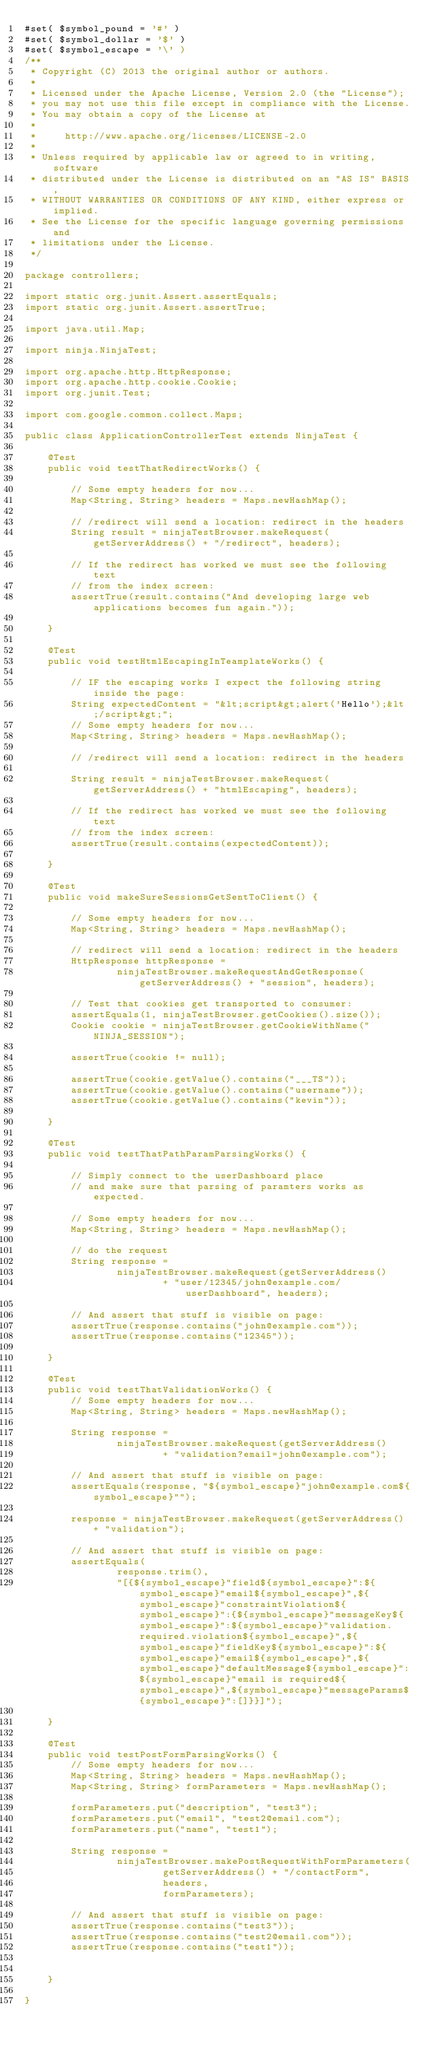Convert code to text. <code><loc_0><loc_0><loc_500><loc_500><_Java_>#set( $symbol_pound = '#' )
#set( $symbol_dollar = '$' )
#set( $symbol_escape = '\' )
/**
 * Copyright (C) 2013 the original author or authors.
 *
 * Licensed under the Apache License, Version 2.0 (the "License");
 * you may not use this file except in compliance with the License.
 * You may obtain a copy of the License at
 *
 *     http://www.apache.org/licenses/LICENSE-2.0
 *
 * Unless required by applicable law or agreed to in writing, software
 * distributed under the License is distributed on an "AS IS" BASIS,
 * WITHOUT WARRANTIES OR CONDITIONS OF ANY KIND, either express or implied.
 * See the License for the specific language governing permissions and
 * limitations under the License.
 */

package controllers;

import static org.junit.Assert.assertEquals;
import static org.junit.Assert.assertTrue;

import java.util.Map;

import ninja.NinjaTest;

import org.apache.http.HttpResponse;
import org.apache.http.cookie.Cookie;
import org.junit.Test;

import com.google.common.collect.Maps;

public class ApplicationControllerTest extends NinjaTest {

    @Test
    public void testThatRedirectWorks() {

        // Some empty headers for now...
        Map<String, String> headers = Maps.newHashMap();

        // /redirect will send a location: redirect in the headers
        String result = ninjaTestBrowser.makeRequest(getServerAddress() + "/redirect", headers);

        // If the redirect has worked we must see the following text
        // from the index screen:
        assertTrue(result.contains("And developing large web applications becomes fun again."));

    }

    @Test
    public void testHtmlEscapingInTeamplateWorks() {

        // IF the escaping works I expect the following string inside the page:
        String expectedContent = "&lt;script&gt;alert('Hello');&lt;/script&gt;";
        // Some empty headers for now...
        Map<String, String> headers = Maps.newHashMap();

        // /redirect will send a location: redirect in the headers

        String result = ninjaTestBrowser.makeRequest(getServerAddress() + "htmlEscaping", headers);

        // If the redirect has worked we must see the following text
        // from the index screen:
        assertTrue(result.contains(expectedContent));

    }

    @Test
    public void makeSureSessionsGetSentToClient() {

        // Some empty headers for now...
        Map<String, String> headers = Maps.newHashMap();

        // redirect will send a location: redirect in the headers
        HttpResponse httpResponse =
                ninjaTestBrowser.makeRequestAndGetResponse(getServerAddress() + "session", headers);

        // Test that cookies get transported to consumer:
        assertEquals(1, ninjaTestBrowser.getCookies().size());
        Cookie cookie = ninjaTestBrowser.getCookieWithName("NINJA_SESSION");

        assertTrue(cookie != null);

        assertTrue(cookie.getValue().contains("___TS"));
        assertTrue(cookie.getValue().contains("username"));
        assertTrue(cookie.getValue().contains("kevin"));

    }

    @Test
    public void testThatPathParamParsingWorks() {

        // Simply connect to the userDashboard place
        // and make sure that parsing of paramters works as expected.

        // Some empty headers for now...
        Map<String, String> headers = Maps.newHashMap();

        // do the request
        String response =
                ninjaTestBrowser.makeRequest(getServerAddress()
                        + "user/12345/john@example.com/userDashboard", headers);

        // And assert that stuff is visible on page:
        assertTrue(response.contains("john@example.com"));
        assertTrue(response.contains("12345"));

    }

    @Test
    public void testThatValidationWorks() {
        // Some empty headers for now...
        Map<String, String> headers = Maps.newHashMap();

        String response =
                ninjaTestBrowser.makeRequest(getServerAddress()
                        + "validation?email=john@example.com");

        // And assert that stuff is visible on page:
        assertEquals(response, "${symbol_escape}"john@example.com${symbol_escape}"");

        response = ninjaTestBrowser.makeRequest(getServerAddress() + "validation");

        // And assert that stuff is visible on page:
        assertEquals(
                response.trim(),
                "[{${symbol_escape}"field${symbol_escape}":${symbol_escape}"email${symbol_escape}",${symbol_escape}"constraintViolation${symbol_escape}":{${symbol_escape}"messageKey${symbol_escape}":${symbol_escape}"validation.required.violation${symbol_escape}",${symbol_escape}"fieldKey${symbol_escape}":${symbol_escape}"email${symbol_escape}",${symbol_escape}"defaultMessage${symbol_escape}":${symbol_escape}"email is required${symbol_escape}",${symbol_escape}"messageParams${symbol_escape}":[]}}]");

    }

    @Test
    public void testPostFormParsingWorks() {
        // Some empty headers for now...
        Map<String, String> headers = Maps.newHashMap();
        Map<String, String> formParameters = Maps.newHashMap();

        formParameters.put("description", "test3");
        formParameters.put("email", "test2@email.com");
        formParameters.put("name", "test1");

        String response =
                ninjaTestBrowser.makePostRequestWithFormParameters(
                        getServerAddress() + "/contactForm",
                        headers,
                        formParameters);

        // And assert that stuff is visible on page:
        assertTrue(response.contains("test3"));
        assertTrue(response.contains("test2@email.com"));
        assertTrue(response.contains("test1"));


    }

}
</code> 